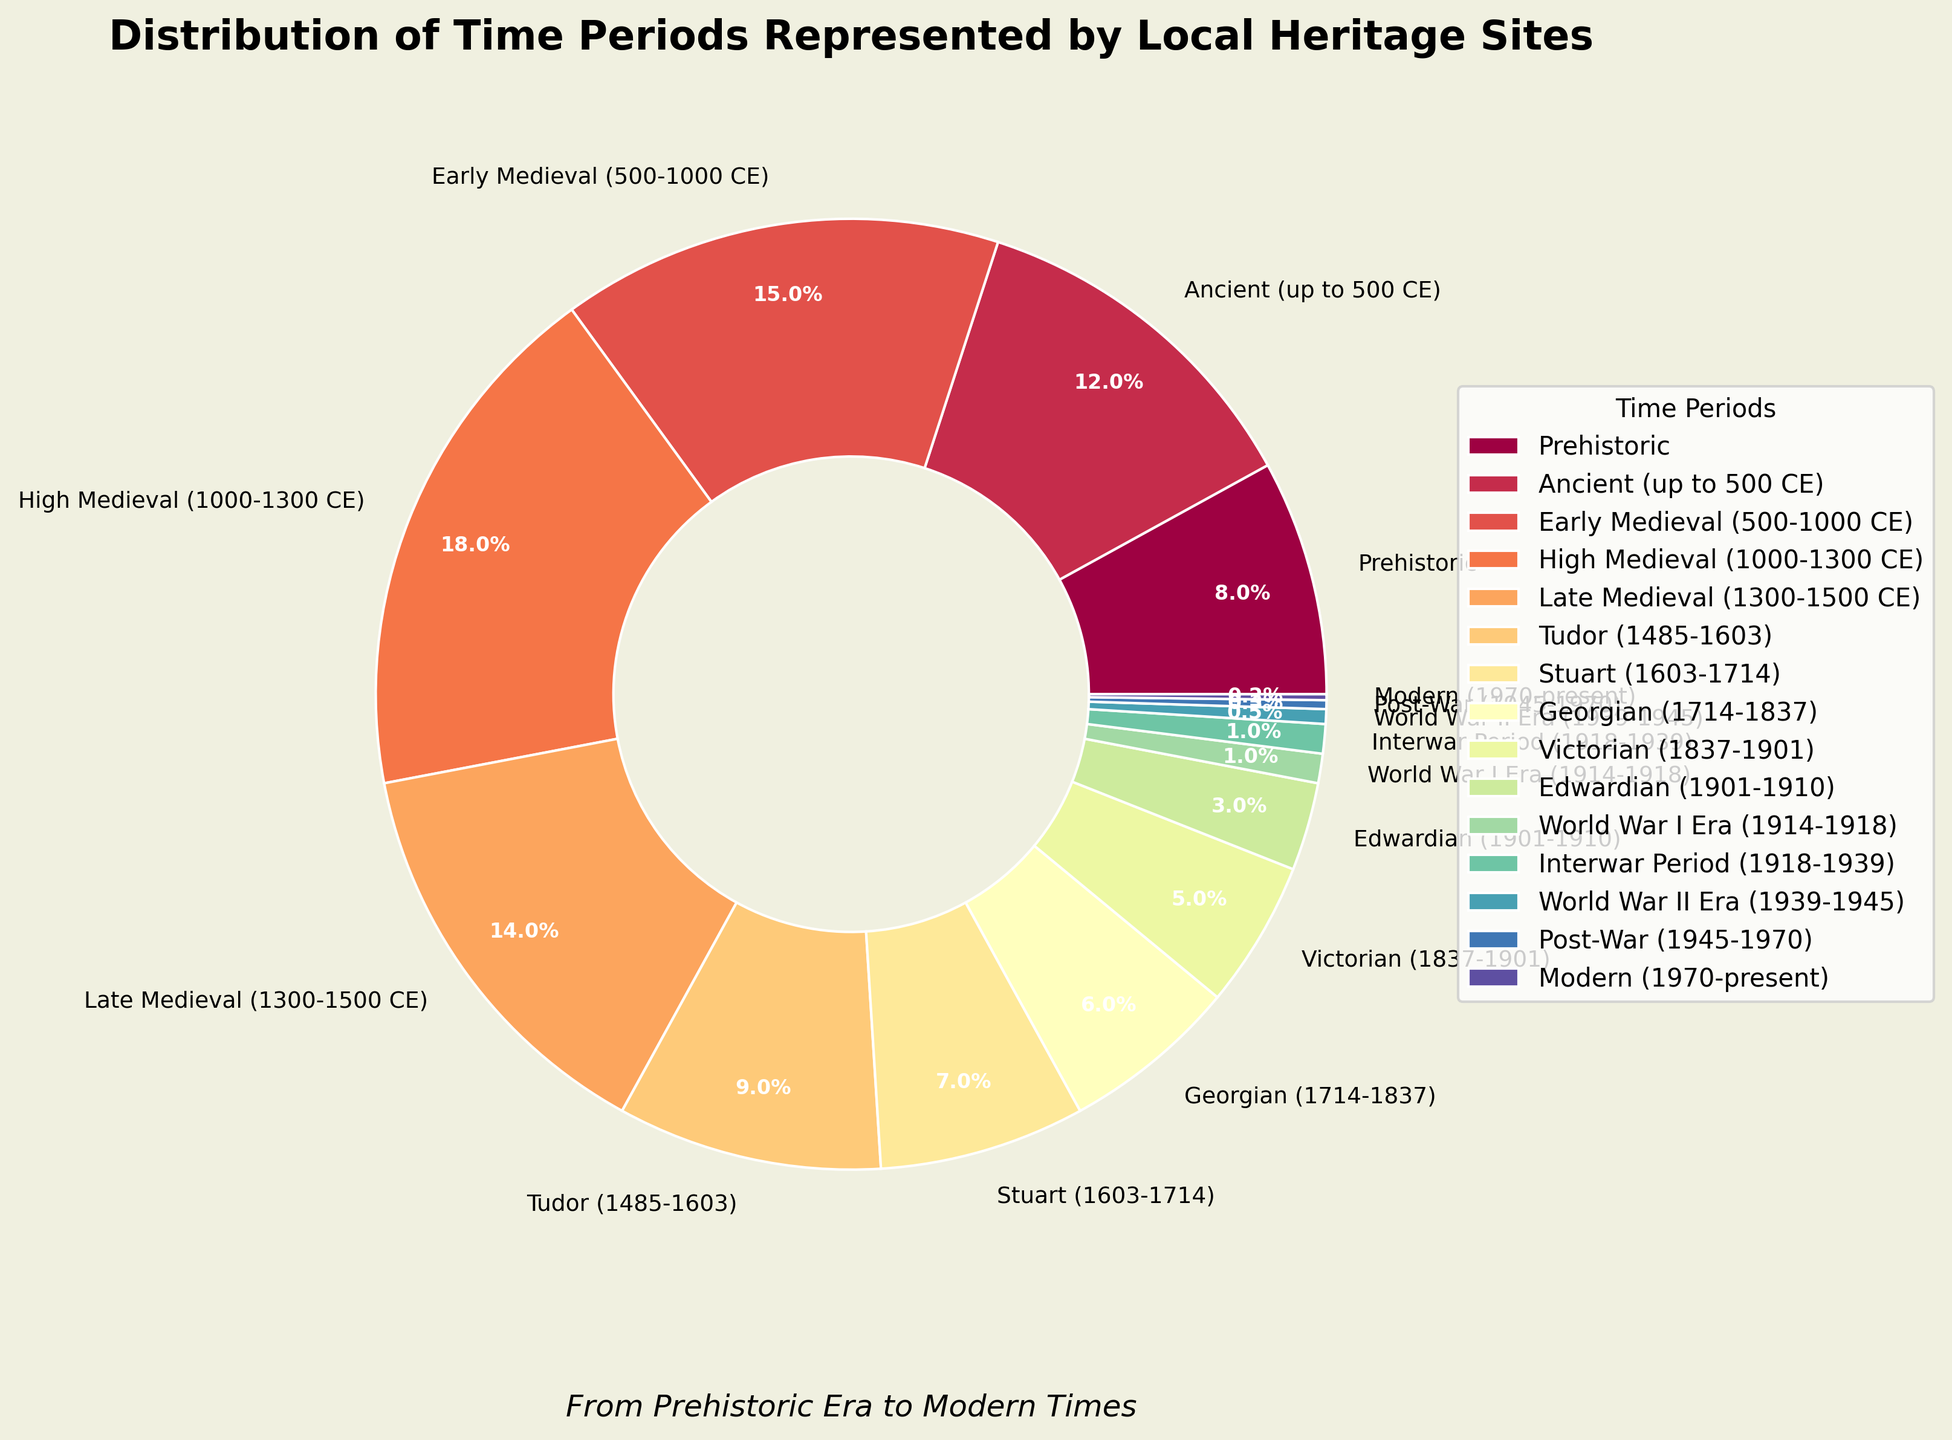What's the total percentage of heritage sites from the Tudor to Victorian era? To find the total percentage of heritage sites from the Tudor to Victorian era, sum their individual percentages: Tudor (9%), Stuart (7%), Georgian (6%), and Victorian (5%). 9% + 7% + 6% + 5% = 27%.
Answer: 27% Which time period has the highest representation in heritage sites? The time periods and their percentages are given. The time period with the highest percentage is High Medieval (1000-1300 CE) with 18%.
Answer: High Medieval (1000-1300 CE) Which period has a smaller representation, the Edwardian era or the Interwar period? The Edwardian period has a percentage of 3%, and the Interwar period has a percentage of 1%. Therefore, the Interwar period has a smaller representation.
Answer: Interwar period What is the percentage difference between the Ancient (up to 500 CE) and Late Medieval (1300-1500 CE) periods? The percentage for the Ancient period is 12%, and for the Late Medieval period, it's 14%. The difference is calculated as 14% - 12% = 2%.
Answer: 2% How many eras in the chart represent less than 5% of heritage sites? The eras representing less than 5% are: Edwardian (3%), World War I Era (1%), Interwar Period (1%), World War II Era (0.5%), Post-War (0.3%), and Modern (0.2%). There are 6 such periods.
Answer: 6 What are the combined representations of prehistoric and ancient eras? To find the combined percentage of the Prehistoric (8%) and Ancient (12%) eras, sum the two values: 8% + 12% = 20%.
Answer: 20% If you combine the Stuart and Georgian periods, do they surpass the Early Medieval period in their combined representation? The Stuart period represents 7% and the Georgian period represents 6%, totaling 13%. The Early Medieval period represents 15%, so 13% does not surpass 15%.
Answer: No 